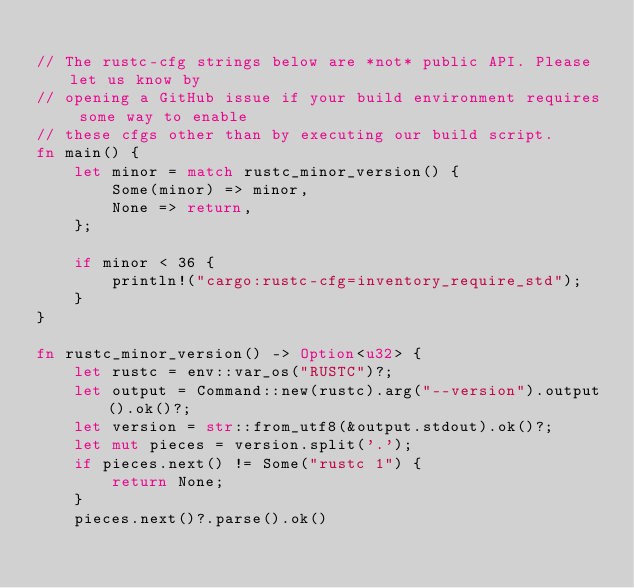<code> <loc_0><loc_0><loc_500><loc_500><_Rust_>
// The rustc-cfg strings below are *not* public API. Please let us know by
// opening a GitHub issue if your build environment requires some way to enable
// these cfgs other than by executing our build script.
fn main() {
    let minor = match rustc_minor_version() {
        Some(minor) => minor,
        None => return,
    };

    if minor < 36 {
        println!("cargo:rustc-cfg=inventory_require_std");
    }
}

fn rustc_minor_version() -> Option<u32> {
    let rustc = env::var_os("RUSTC")?;
    let output = Command::new(rustc).arg("--version").output().ok()?;
    let version = str::from_utf8(&output.stdout).ok()?;
    let mut pieces = version.split('.');
    if pieces.next() != Some("rustc 1") {
        return None;
    }
    pieces.next()?.parse().ok()</code> 